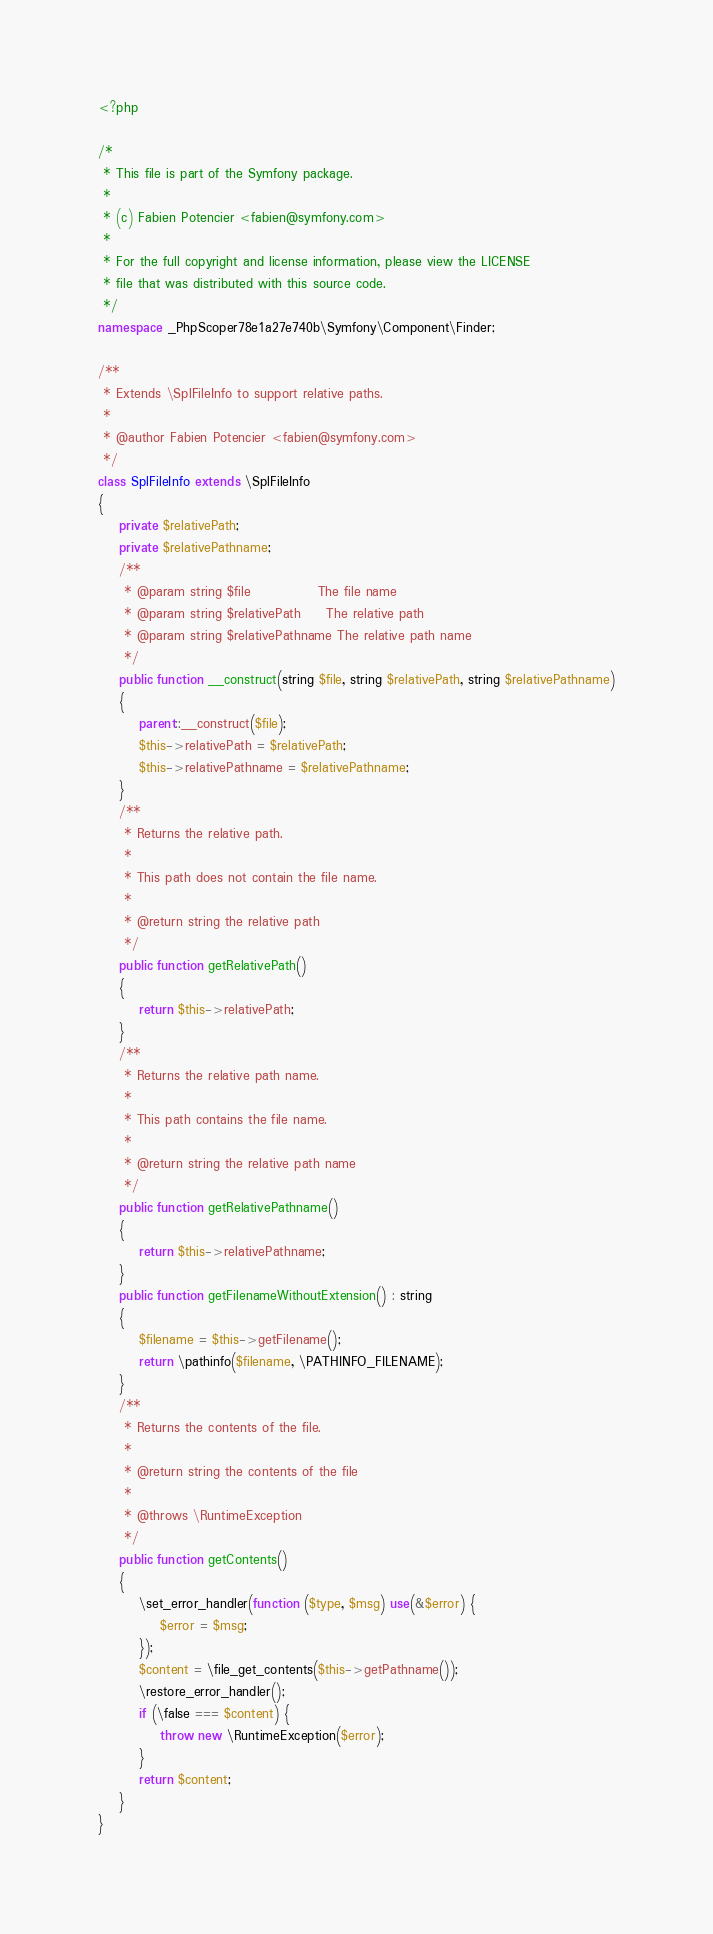Convert code to text. <code><loc_0><loc_0><loc_500><loc_500><_PHP_><?php

/*
 * This file is part of the Symfony package.
 *
 * (c) Fabien Potencier <fabien@symfony.com>
 *
 * For the full copyright and license information, please view the LICENSE
 * file that was distributed with this source code.
 */
namespace _PhpScoper78e1a27e740b\Symfony\Component\Finder;

/**
 * Extends \SplFileInfo to support relative paths.
 *
 * @author Fabien Potencier <fabien@symfony.com>
 */
class SplFileInfo extends \SplFileInfo
{
    private $relativePath;
    private $relativePathname;
    /**
     * @param string $file             The file name
     * @param string $relativePath     The relative path
     * @param string $relativePathname The relative path name
     */
    public function __construct(string $file, string $relativePath, string $relativePathname)
    {
        parent::__construct($file);
        $this->relativePath = $relativePath;
        $this->relativePathname = $relativePathname;
    }
    /**
     * Returns the relative path.
     *
     * This path does not contain the file name.
     *
     * @return string the relative path
     */
    public function getRelativePath()
    {
        return $this->relativePath;
    }
    /**
     * Returns the relative path name.
     *
     * This path contains the file name.
     *
     * @return string the relative path name
     */
    public function getRelativePathname()
    {
        return $this->relativePathname;
    }
    public function getFilenameWithoutExtension() : string
    {
        $filename = $this->getFilename();
        return \pathinfo($filename, \PATHINFO_FILENAME);
    }
    /**
     * Returns the contents of the file.
     *
     * @return string the contents of the file
     *
     * @throws \RuntimeException
     */
    public function getContents()
    {
        \set_error_handler(function ($type, $msg) use(&$error) {
            $error = $msg;
        });
        $content = \file_get_contents($this->getPathname());
        \restore_error_handler();
        if (\false === $content) {
            throw new \RuntimeException($error);
        }
        return $content;
    }
}
</code> 